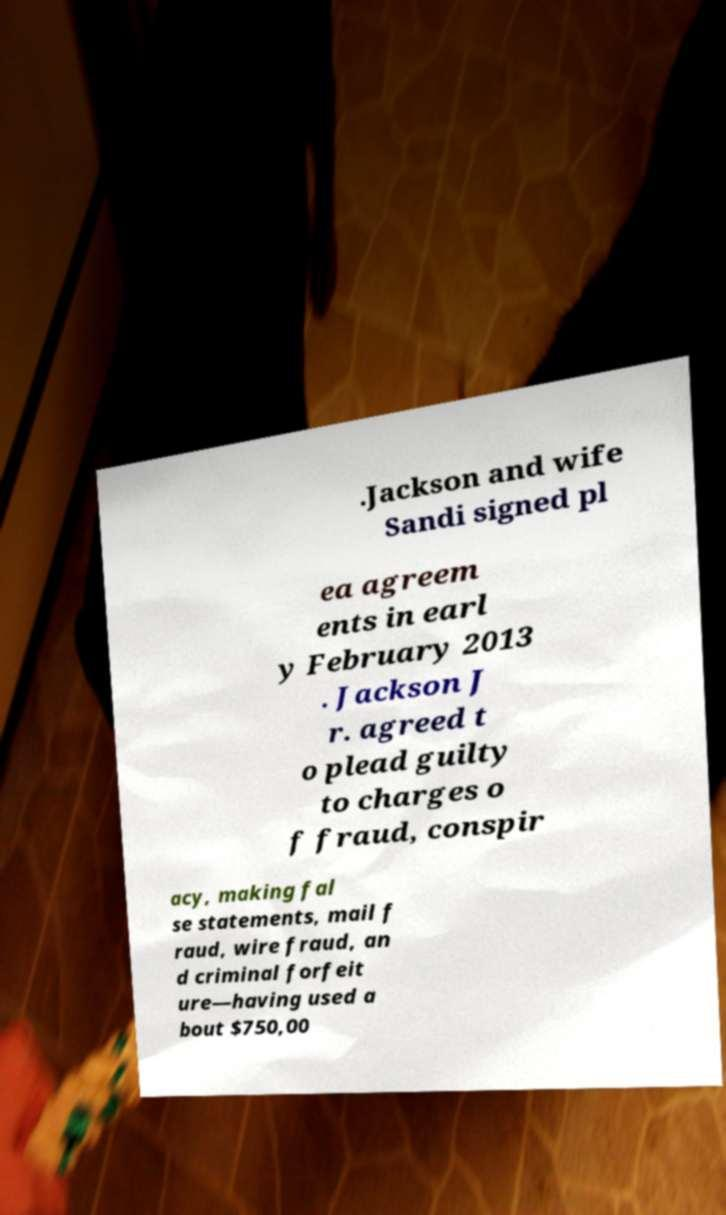What messages or text are displayed in this image? I need them in a readable, typed format. .Jackson and wife Sandi signed pl ea agreem ents in earl y February 2013 . Jackson J r. agreed t o plead guilty to charges o f fraud, conspir acy, making fal se statements, mail f raud, wire fraud, an d criminal forfeit ure—having used a bout $750,00 